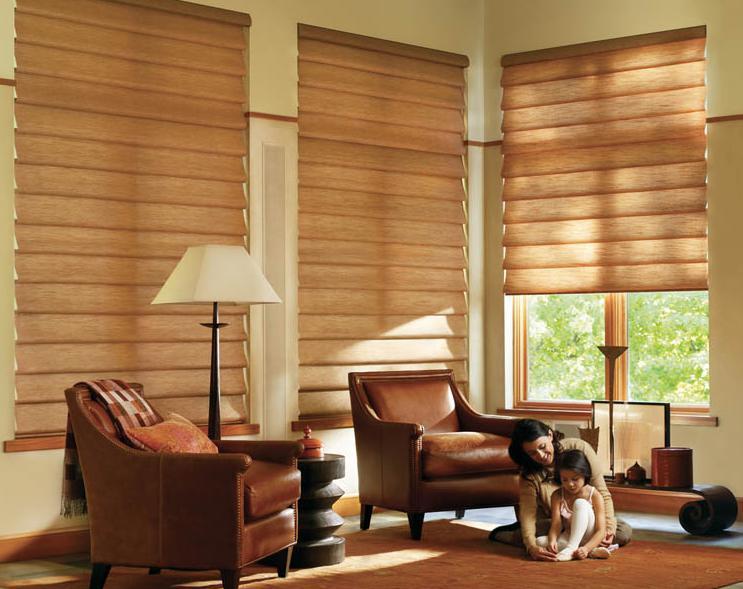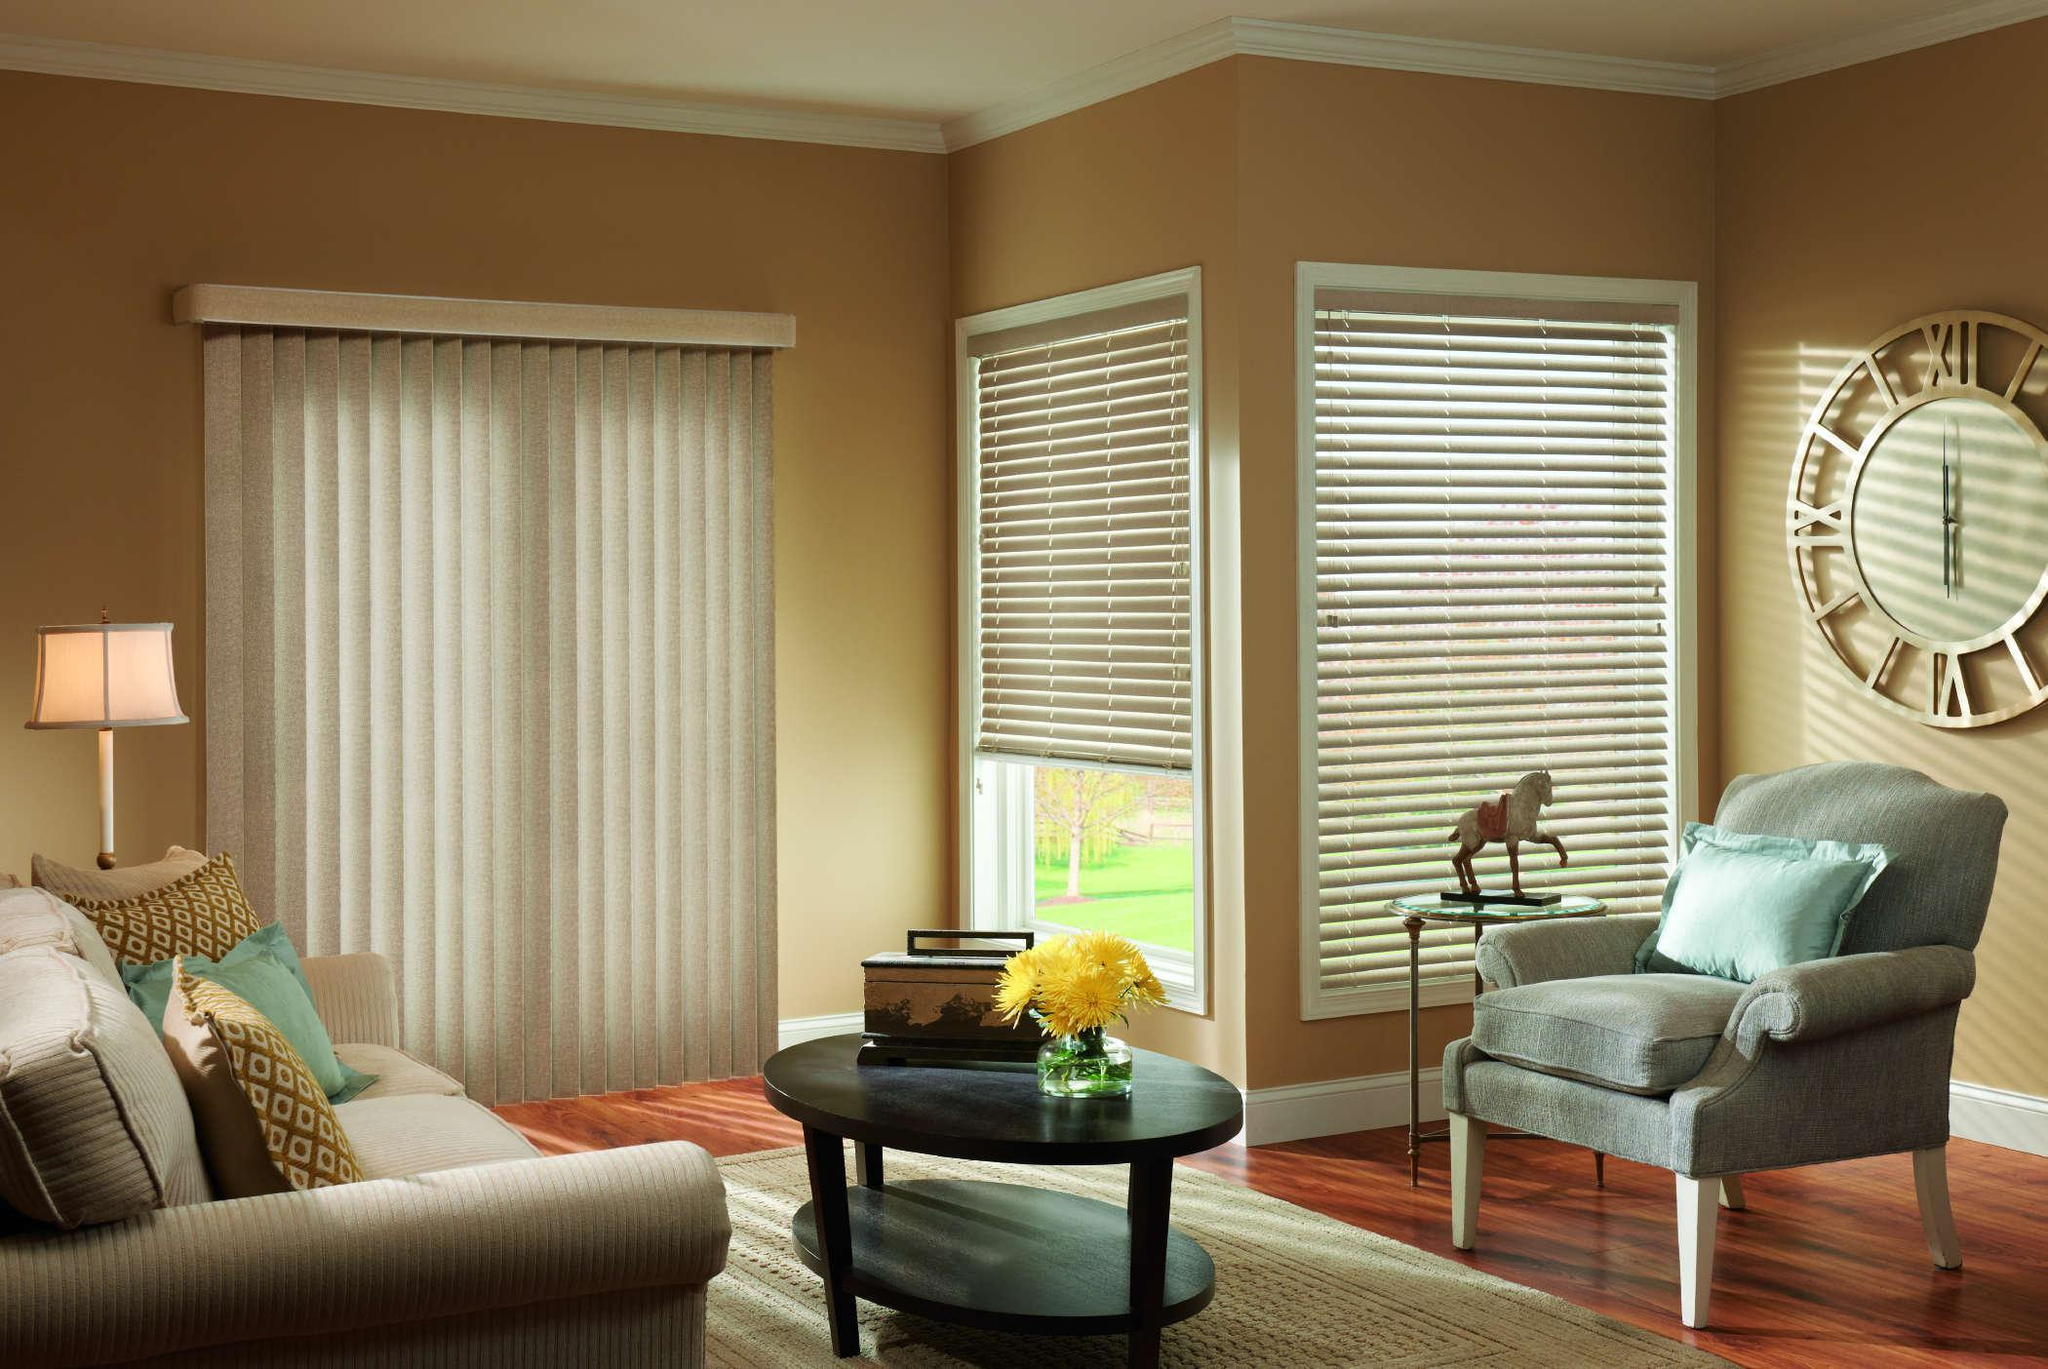The first image is the image on the left, the second image is the image on the right. Considering the images on both sides, is "A window blind is partially pulled up in both images." valid? Answer yes or no. Yes. The first image is the image on the left, the second image is the image on the right. Assess this claim about the two images: "There is a total of seven shades.". Correct or not? Answer yes or no. No. 